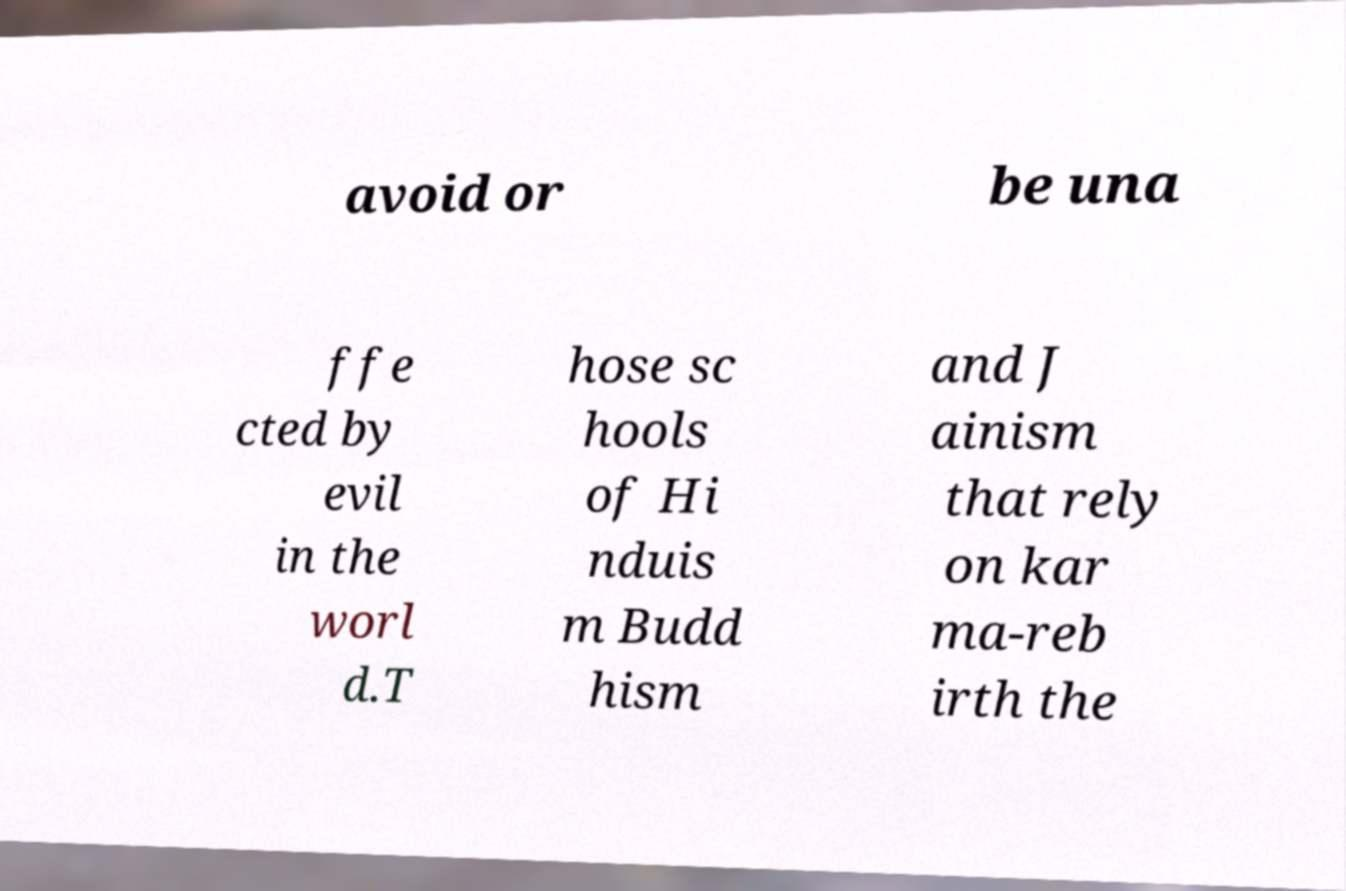Can you accurately transcribe the text from the provided image for me? avoid or be una ffe cted by evil in the worl d.T hose sc hools of Hi nduis m Budd hism and J ainism that rely on kar ma-reb irth the 